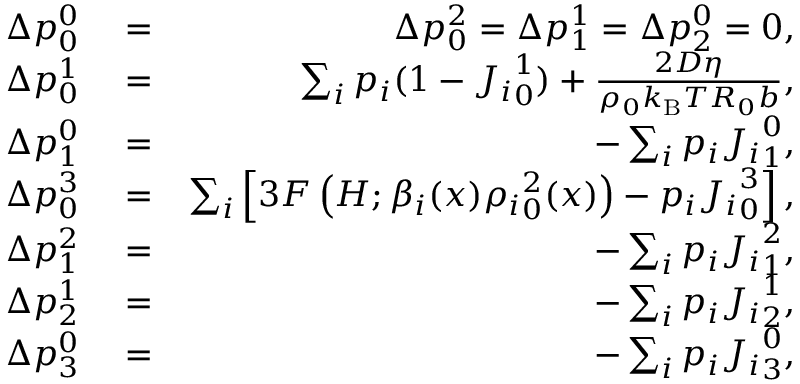Convert formula to latex. <formula><loc_0><loc_0><loc_500><loc_500>\begin{array} { r l r } { \Delta p _ { 0 } ^ { 0 } } & = } & { \Delta p _ { 0 } ^ { 2 } = \Delta p _ { 1 } ^ { 1 } = \Delta p _ { 2 } ^ { 0 } = 0 , } \\ { \Delta p _ { 0 } ^ { 1 } } & = } & { \sum _ { i } p _ { i } ( 1 - { J _ { i } } _ { 0 } ^ { 1 } ) + \frac { 2 D \eta } { \rho _ { 0 } k _ { B } T R _ { 0 } b } , } \\ { \Delta p _ { 1 } ^ { 0 } } & = } & { - \sum _ { i } p _ { i } { J _ { i } } _ { 1 } ^ { 0 } , } \\ { \Delta p _ { 0 } ^ { 3 } } & = } & { \sum _ { i } \left [ 3 F \left ( H ; \beta _ { i } ( x ) { \rho _ { i } } _ { 0 } ^ { 2 } ( x ) \right ) - p _ { i } { J _ { i } } _ { 0 } ^ { 3 } \right ] , } \\ { \Delta p _ { 1 } ^ { 2 } } & = } & { - \sum _ { i } p _ { i } { J _ { i } } _ { 1 } ^ { 2 } , } \\ { \Delta p _ { 2 } ^ { 1 } } & = } & { - \sum _ { i } p _ { i } { J _ { i } } _ { 2 } ^ { 1 } , } \\ { \Delta p _ { 3 } ^ { 0 } } & = } & { - \sum _ { i } p _ { i } { J _ { i } } _ { 3 } ^ { 0 } , } \end{array}</formula> 